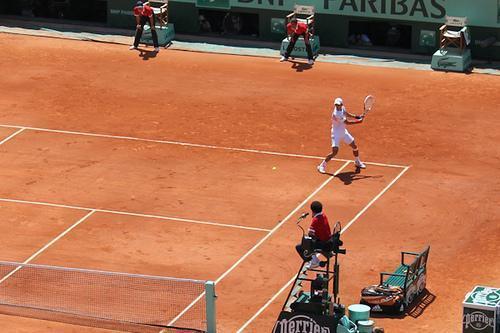How many line judges are sitting down?
Give a very brief answer. 1. 